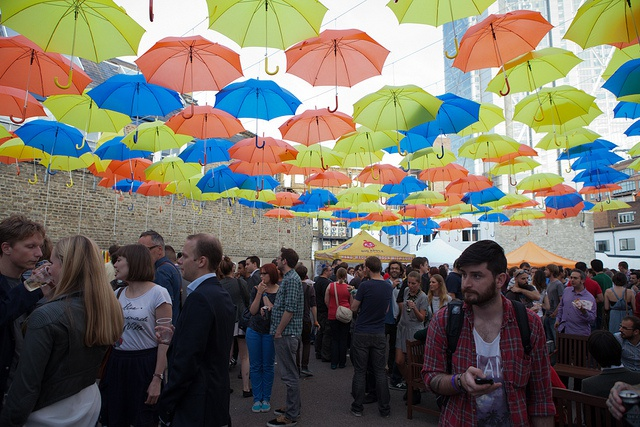Describe the objects in this image and their specific colors. I can see umbrella in olive, khaki, white, salmon, and blue tones, people in olive, black, gray, and maroon tones, people in olive, black, maroon, gray, and purple tones, people in olive, black, and gray tones, and people in olive, black, and gray tones in this image. 